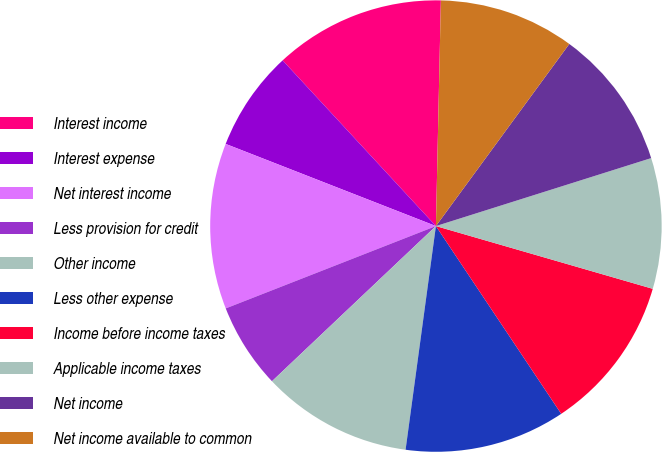Convert chart. <chart><loc_0><loc_0><loc_500><loc_500><pie_chart><fcel>Interest income<fcel>Interest expense<fcel>Net interest income<fcel>Less provision for credit<fcel>Other income<fcel>Less other expense<fcel>Income before income taxes<fcel>Applicable income taxes<fcel>Net income<fcel>Net income available to common<nl><fcel>12.23%<fcel>7.19%<fcel>11.87%<fcel>6.12%<fcel>10.79%<fcel>11.51%<fcel>11.15%<fcel>9.35%<fcel>10.07%<fcel>9.71%<nl></chart> 